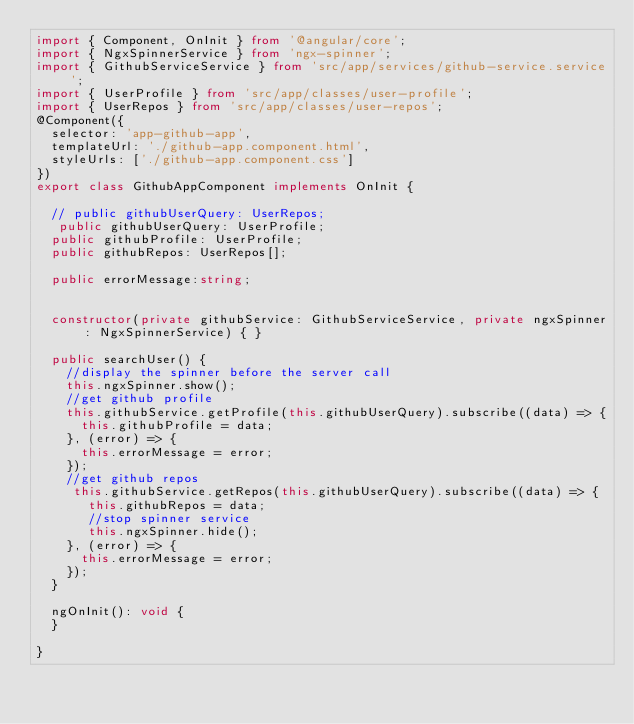Convert code to text. <code><loc_0><loc_0><loc_500><loc_500><_TypeScript_>import { Component, OnInit } from '@angular/core';
import { NgxSpinnerService } from 'ngx-spinner';
import { GithubServiceService } from 'src/app/services/github-service.service';
import { UserProfile } from 'src/app/classes/user-profile';
import { UserRepos } from 'src/app/classes/user-repos';
@Component({
  selector: 'app-github-app',
  templateUrl: './github-app.component.html',
  styleUrls: ['./github-app.component.css']
})
export class GithubAppComponent implements OnInit {

  // public githubUserQuery: UserRepos;
   public githubUserQuery: UserProfile;
  public githubProfile: UserProfile;
  public githubRepos: UserRepos[];
 
  public errorMessage:string;


  constructor(private githubService: GithubServiceService, private ngxSpinner: NgxSpinnerService) { }
  
  public searchUser() {
    //display the spinner before the server call
    this.ngxSpinner.show();
    //get github profile
    this.githubService.getProfile(this.githubUserQuery).subscribe((data) => {
      this.githubProfile = data;
    }, (error) => {
      this.errorMessage = error;
    });
    //get github repos
     this.githubService.getRepos(this.githubUserQuery).subscribe((data) => {
       this.githubRepos = data;
       //stop spinner service
       this.ngxSpinner.hide();
    }, (error) => {
      this.errorMessage = error;
    });
  }

  ngOnInit(): void {
  }

}

</code> 